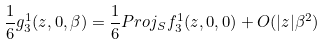Convert formula to latex. <formula><loc_0><loc_0><loc_500><loc_500>\frac { 1 } { 6 } g _ { 3 } ^ { 1 } ( z , 0 , \beta ) = \frac { 1 } { 6 } P r o j _ { S } f _ { 3 } ^ { 1 } ( z , 0 , 0 ) + O ( | z | \beta ^ { 2 } )</formula> 